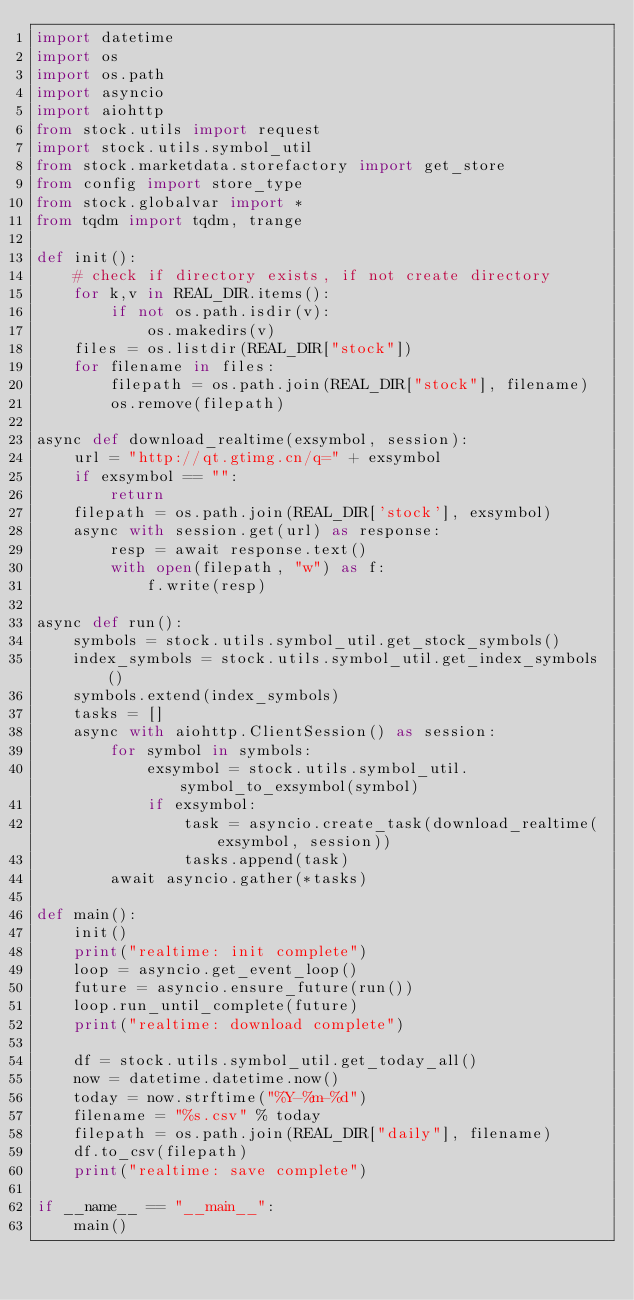<code> <loc_0><loc_0><loc_500><loc_500><_Python_>import datetime
import os
import os.path
import asyncio
import aiohttp
from stock.utils import request
import stock.utils.symbol_util
from stock.marketdata.storefactory import get_store
from config import store_type
from stock.globalvar import *
from tqdm import tqdm, trange

def init():
    # check if directory exists, if not create directory
    for k,v in REAL_DIR.items():
        if not os.path.isdir(v):
            os.makedirs(v)
    files = os.listdir(REAL_DIR["stock"])
    for filename in files:
        filepath = os.path.join(REAL_DIR["stock"], filename)
        os.remove(filepath)

async def download_realtime(exsymbol, session):
    url = "http://qt.gtimg.cn/q=" + exsymbol
    if exsymbol == "":
        return
    filepath = os.path.join(REAL_DIR['stock'], exsymbol)
    async with session.get(url) as response:
        resp = await response.text()
        with open(filepath, "w") as f:
            f.write(resp)

async def run():
    symbols = stock.utils.symbol_util.get_stock_symbols()
    index_symbols = stock.utils.symbol_util.get_index_symbols()
    symbols.extend(index_symbols)
    tasks = []
    async with aiohttp.ClientSession() as session:
        for symbol in symbols:
            exsymbol = stock.utils.symbol_util.symbol_to_exsymbol(symbol)
            if exsymbol:
                task = asyncio.create_task(download_realtime(exsymbol, session))
                tasks.append(task)
        await asyncio.gather(*tasks)

def main():
    init()
    print("realtime: init complete")
    loop = asyncio.get_event_loop()
    future = asyncio.ensure_future(run())
    loop.run_until_complete(future)
    print("realtime: download complete")

    df = stock.utils.symbol_util.get_today_all()
    now = datetime.datetime.now()
    today = now.strftime("%Y-%m-%d")
    filename = "%s.csv" % today
    filepath = os.path.join(REAL_DIR["daily"], filename)
    df.to_csv(filepath)
    print("realtime: save complete")

if __name__ == "__main__":
    main()
</code> 